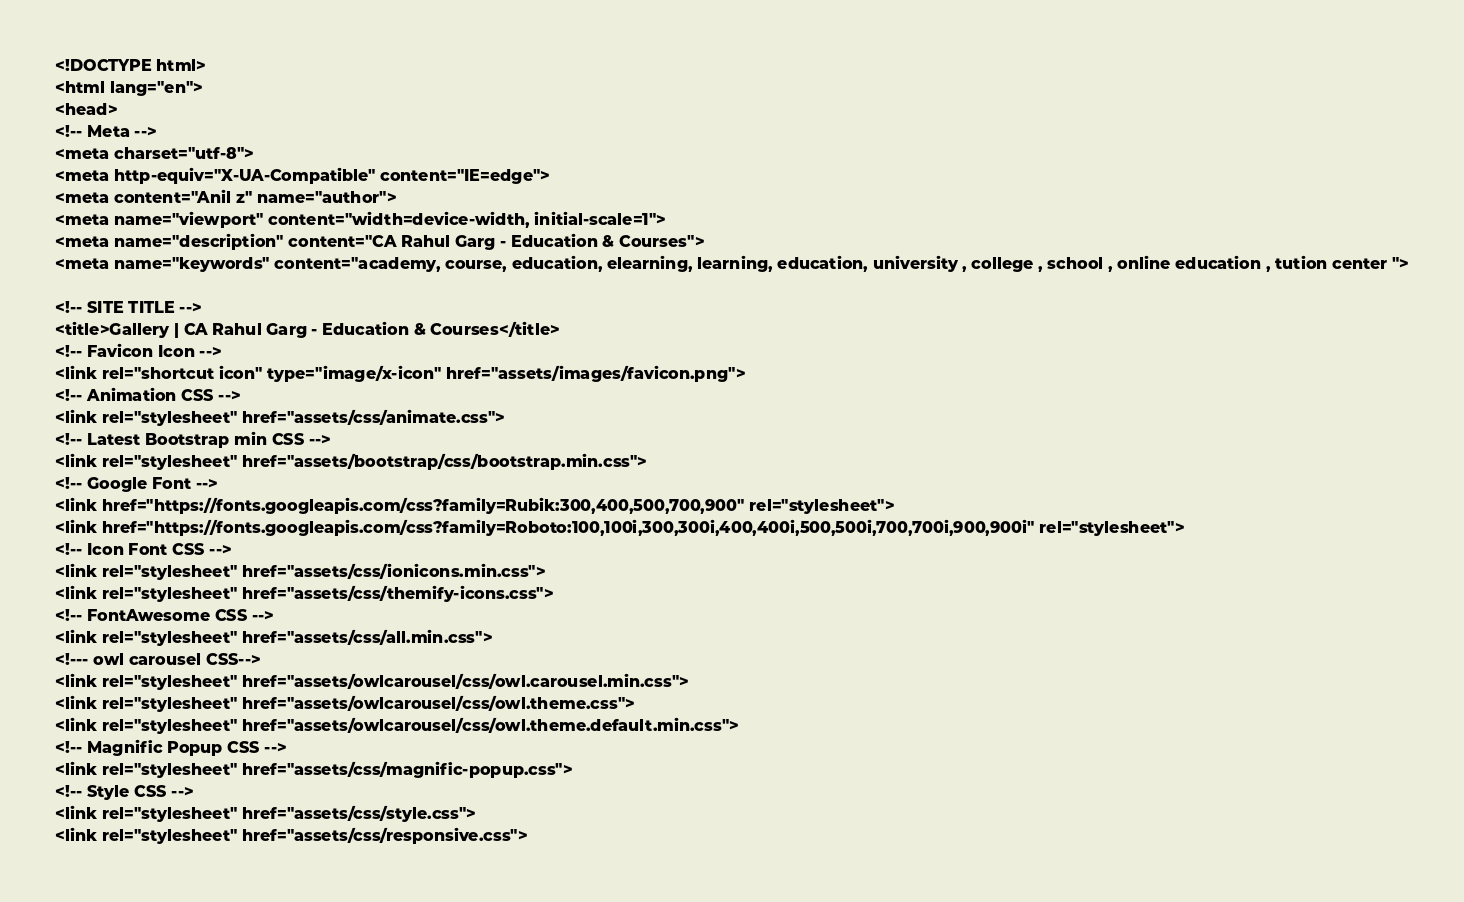<code> <loc_0><loc_0><loc_500><loc_500><_PHP_><!DOCTYPE html>
<html lang="en">
<head>
<!-- Meta -->
<meta charset="utf-8">
<meta http-equiv="X-UA-Compatible" content="IE=edge">
<meta content="Anil z" name="author">
<meta name="viewport" content="width=device-width, initial-scale=1">
<meta name="description" content="CA Rahul Garg - Education & Courses">
<meta name="keywords" content="academy, course, education, elearning, learning, education, university , college , school , online education , tution center ">

<!-- SITE TITLE -->
<title>Gallery | CA Rahul Garg - Education & Courses</title>
<!-- Favicon Icon -->
<link rel="shortcut icon" type="image/x-icon" href="assets/images/favicon.png">
<!-- Animation CSS -->
<link rel="stylesheet" href="assets/css/animate.css">	
<!-- Latest Bootstrap min CSS -->
<link rel="stylesheet" href="assets/bootstrap/css/bootstrap.min.css">
<!-- Google Font -->
<link href="https://fonts.googleapis.com/css?family=Rubik:300,400,500,700,900" rel="stylesheet"> 
<link href="https://fonts.googleapis.com/css?family=Roboto:100,100i,300,300i,400,400i,500,500i,700,700i,900,900i" rel="stylesheet">
<!-- Icon Font CSS -->
<link rel="stylesheet" href="assets/css/ionicons.min.css">
<link rel="stylesheet" href="assets/css/themify-icons.css">
<!-- FontAwesome CSS -->
<link rel="stylesheet" href="assets/css/all.min.css">
<!--- owl carousel CSS-->
<link rel="stylesheet" href="assets/owlcarousel/css/owl.carousel.min.css">
<link rel="stylesheet" href="assets/owlcarousel/css/owl.theme.css">
<link rel="stylesheet" href="assets/owlcarousel/css/owl.theme.default.min.css">
<!-- Magnific Popup CSS -->
<link rel="stylesheet" href="assets/css/magnific-popup.css">
<!-- Style CSS -->
<link rel="stylesheet" href="assets/css/style.css">
<link rel="stylesheet" href="assets/css/responsive.css"></code> 